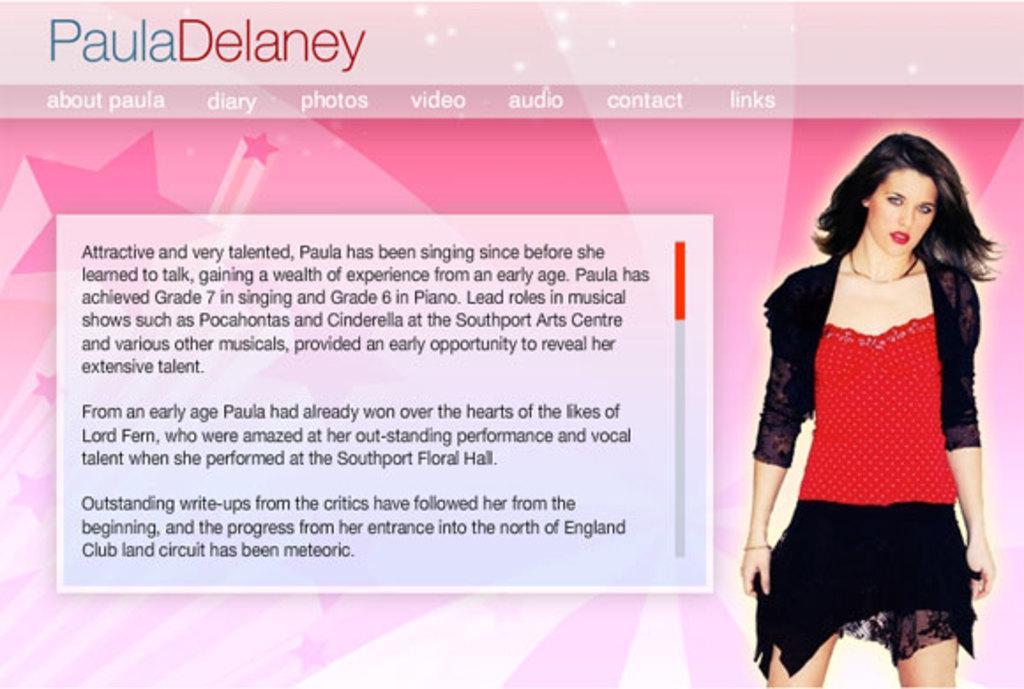Please provide a concise description of this image. In this image we can see that there is a screenshot of a website in which there is a girl on the right side. 